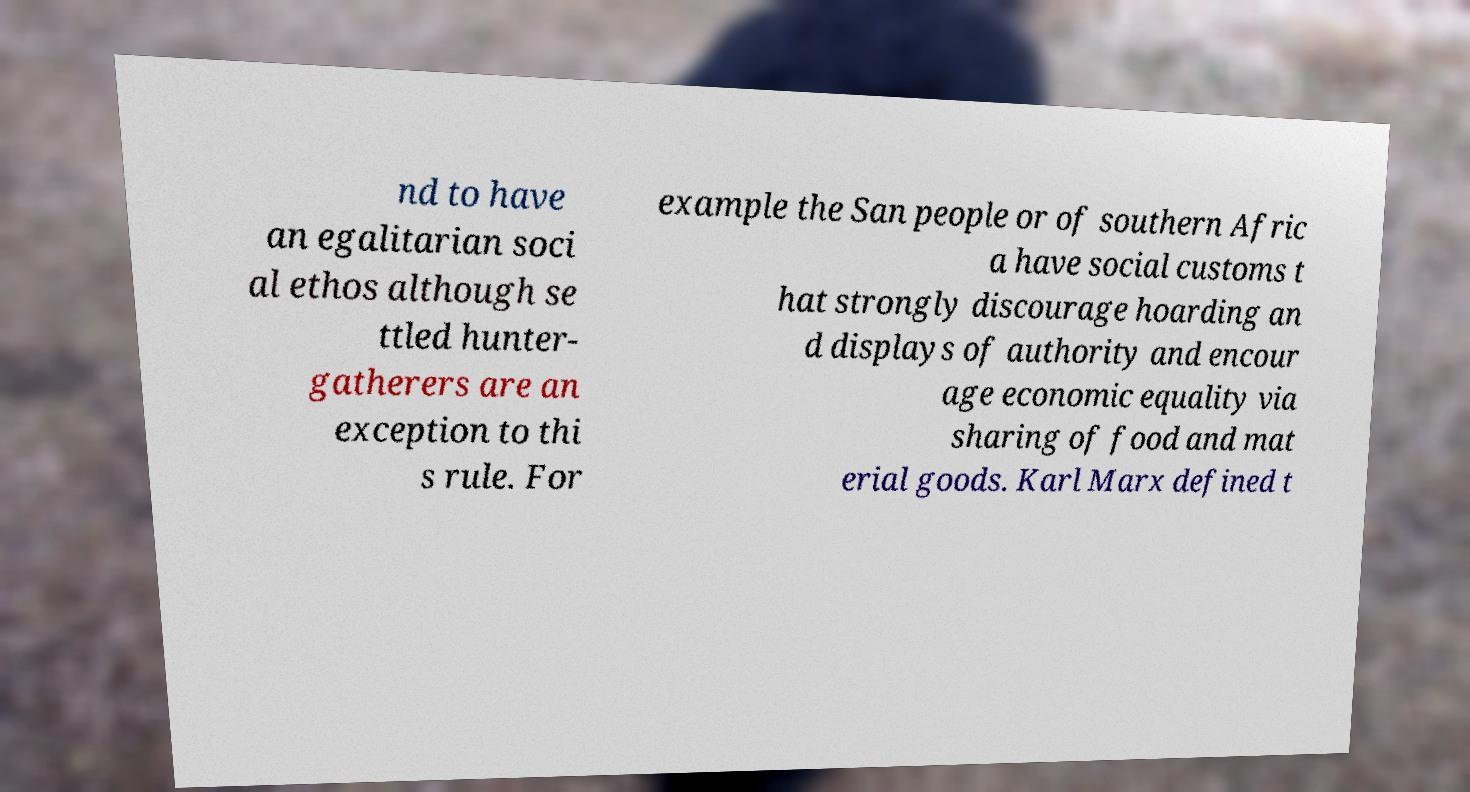What messages or text are displayed in this image? I need them in a readable, typed format. nd to have an egalitarian soci al ethos although se ttled hunter- gatherers are an exception to thi s rule. For example the San people or of southern Afric a have social customs t hat strongly discourage hoarding an d displays of authority and encour age economic equality via sharing of food and mat erial goods. Karl Marx defined t 